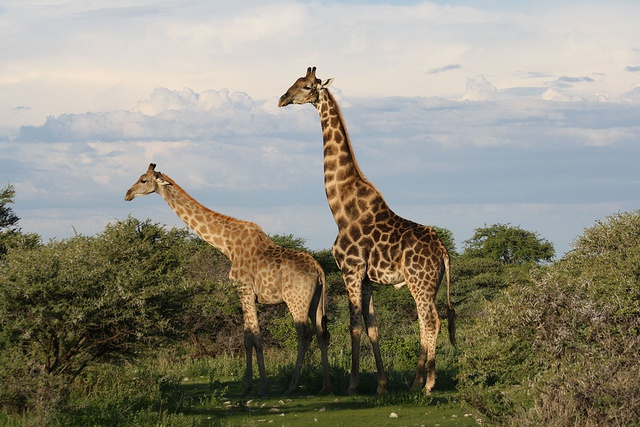Describe the objects in this image and their specific colors. I can see giraffe in lightgray, black, maroon, and tan tones and giraffe in lightgray, black, tan, and olive tones in this image. 